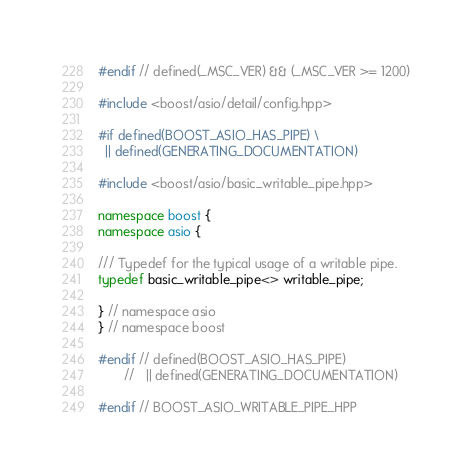<code> <loc_0><loc_0><loc_500><loc_500><_C++_>#endif // defined(_MSC_VER) && (_MSC_VER >= 1200)

#include <boost/asio/detail/config.hpp>

#if defined(BOOST_ASIO_HAS_PIPE) \
  || defined(GENERATING_DOCUMENTATION)

#include <boost/asio/basic_writable_pipe.hpp>

namespace boost {
namespace asio {

/// Typedef for the typical usage of a writable pipe.
typedef basic_writable_pipe<> writable_pipe;

} // namespace asio
} // namespace boost

#endif // defined(BOOST_ASIO_HAS_PIPE)
       //   || defined(GENERATING_DOCUMENTATION)

#endif // BOOST_ASIO_WRITABLE_PIPE_HPP
</code> 